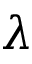Convert formula to latex. <formula><loc_0><loc_0><loc_500><loc_500>\lambda</formula> 